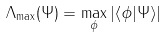Convert formula to latex. <formula><loc_0><loc_0><loc_500><loc_500>\Lambda _ { \max } ( \Psi ) = \underset { \phi } { \max } \left | \left \langle \phi | \Psi \right \rangle \right |</formula> 